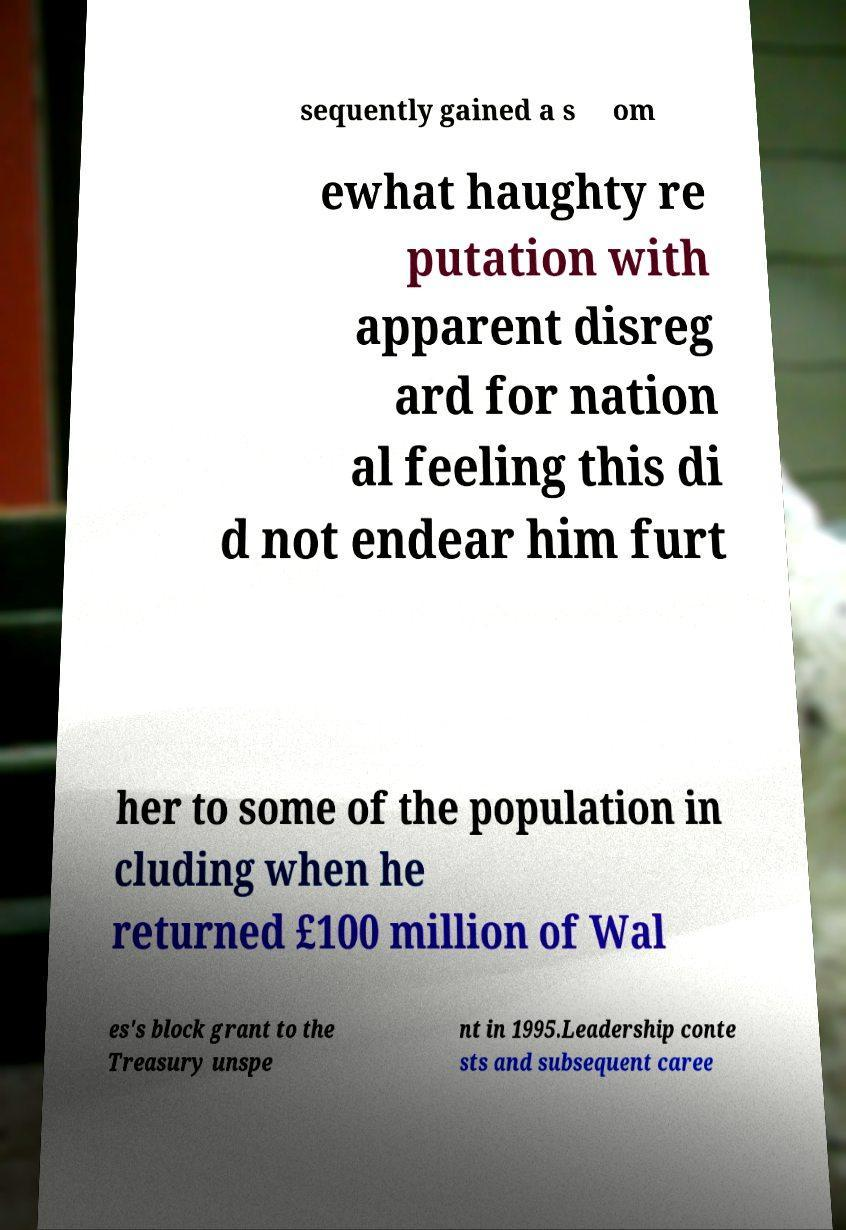Could you extract and type out the text from this image? sequently gained a s om ewhat haughty re putation with apparent disreg ard for nation al feeling this di d not endear him furt her to some of the population in cluding when he returned £100 million of Wal es's block grant to the Treasury unspe nt in 1995.Leadership conte sts and subsequent caree 